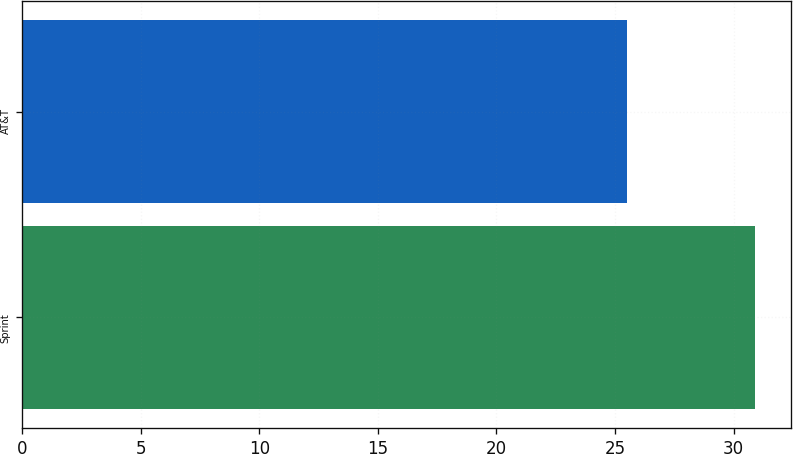Convert chart to OTSL. <chart><loc_0><loc_0><loc_500><loc_500><bar_chart><fcel>Sprint<fcel>AT&T<nl><fcel>30.9<fcel>25.5<nl></chart> 